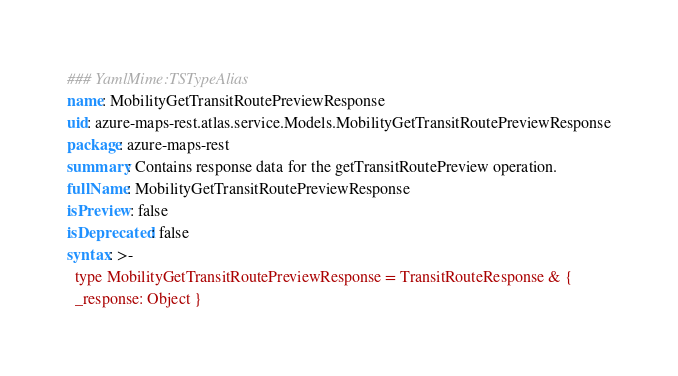Convert code to text. <code><loc_0><loc_0><loc_500><loc_500><_YAML_>### YamlMime:TSTypeAlias
name: MobilityGetTransitRoutePreviewResponse
uid: azure-maps-rest.atlas.service.Models.MobilityGetTransitRoutePreviewResponse
package: azure-maps-rest
summary: Contains response data for the getTransitRoutePreview operation.
fullName: MobilityGetTransitRoutePreviewResponse
isPreview: false
isDeprecated: false
syntax: >-
  type MobilityGetTransitRoutePreviewResponse = TransitRouteResponse & {
  _response: Object }
</code> 